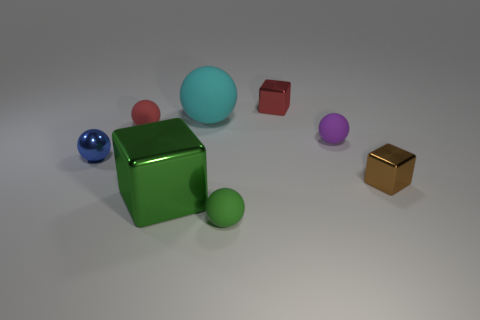The big metal cube has what color?
Provide a succinct answer. Green. Do the shiny thing that is in front of the tiny brown metallic thing and the small matte object on the right side of the red block have the same shape?
Your answer should be compact. No. There is a tiny metal cube in front of the blue thing; what color is it?
Provide a succinct answer. Brown. Are there fewer small red shiny cubes on the right side of the purple ball than small green things to the left of the small green rubber sphere?
Your answer should be compact. No. What number of other things are the same material as the large cyan sphere?
Your answer should be compact. 3. Are the cyan ball and the blue ball made of the same material?
Provide a succinct answer. No. What number of other things are the same size as the purple rubber thing?
Your answer should be compact. 5. Are there the same number of small brown things and tiny cylinders?
Offer a very short reply. No. There is a block left of the red object that is behind the tiny red matte ball; what is its size?
Make the answer very short. Large. There is a tiny matte ball that is in front of the metal cube on the left side of the small cube that is behind the purple matte object; what is its color?
Offer a very short reply. Green. 